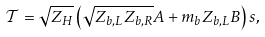Convert formula to latex. <formula><loc_0><loc_0><loc_500><loc_500>\mathcal { T } = \sqrt { Z _ { H } } \left ( \sqrt { Z _ { b , L } Z _ { b , R } } A + m _ { b } Z _ { b , L } B \right ) s ,</formula> 